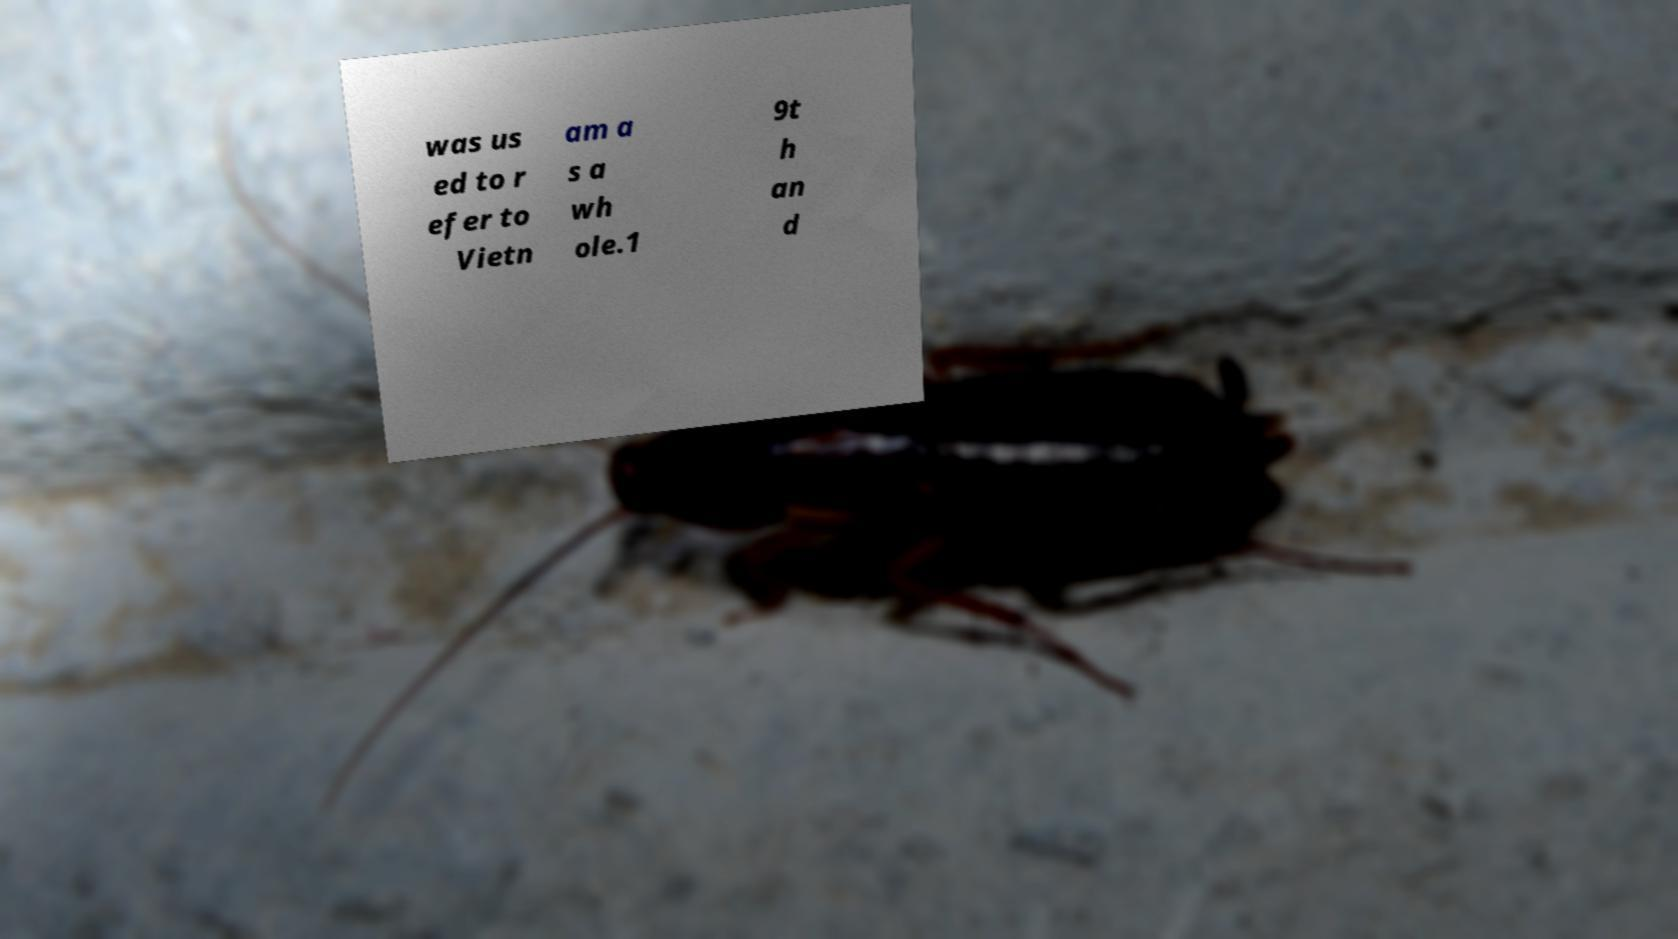Please identify and transcribe the text found in this image. was us ed to r efer to Vietn am a s a wh ole.1 9t h an d 